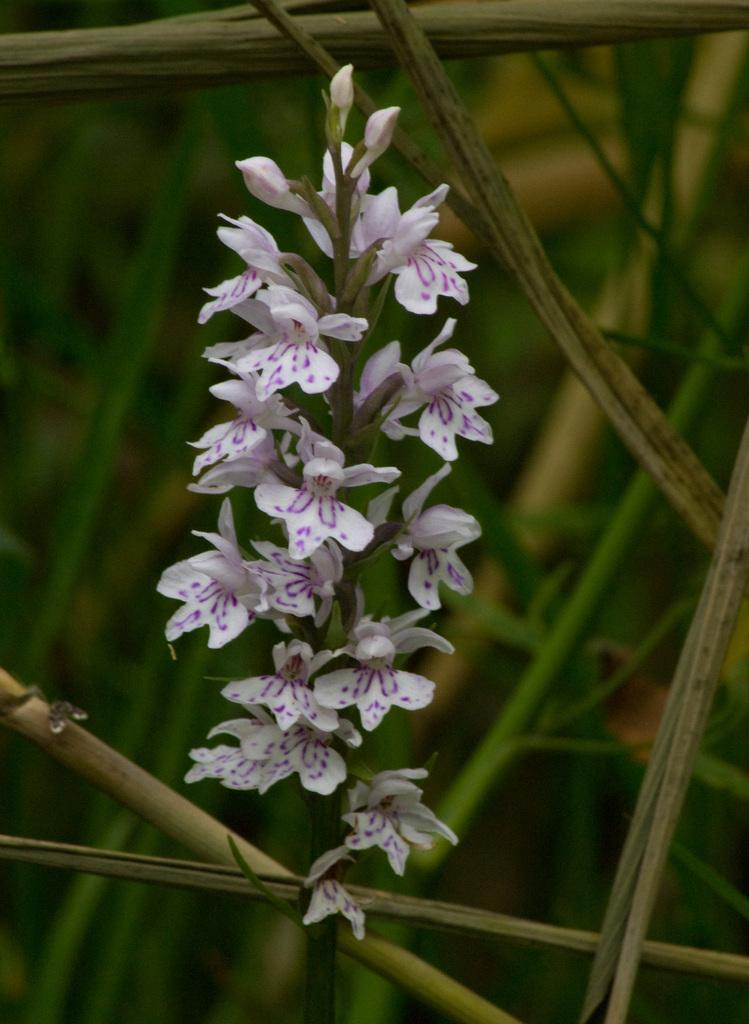What type of plant is in the image? There is a flower plant in the image. What colors can be seen on the flower plant? The flower plant has purple and white colors. How would you describe the background of the image? The background of the image is blurred. What else can be seen in the background besides the blurred area? There are plant branches visible in the background. How does the crow interact with the loss in the image? There is no crow or loss present in the image; it features a flower plant with purple and white colors, a blurred background, and visible plant branches. 